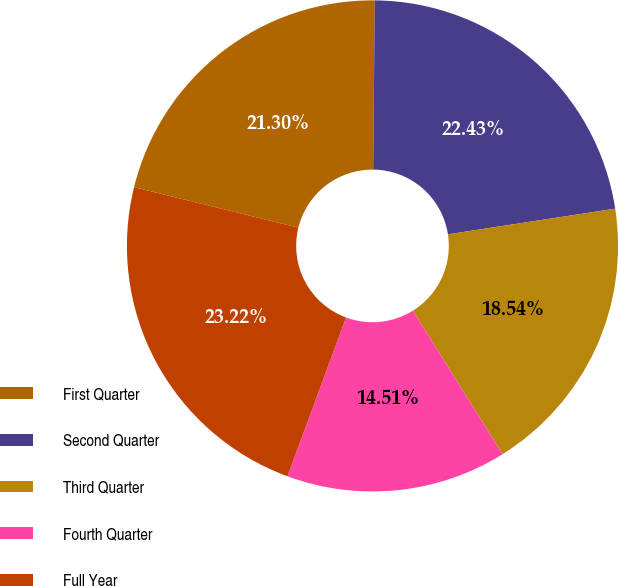Convert chart. <chart><loc_0><loc_0><loc_500><loc_500><pie_chart><fcel>First Quarter<fcel>Second Quarter<fcel>Third Quarter<fcel>Fourth Quarter<fcel>Full Year<nl><fcel>21.3%<fcel>22.43%<fcel>18.54%<fcel>14.51%<fcel>23.22%<nl></chart> 